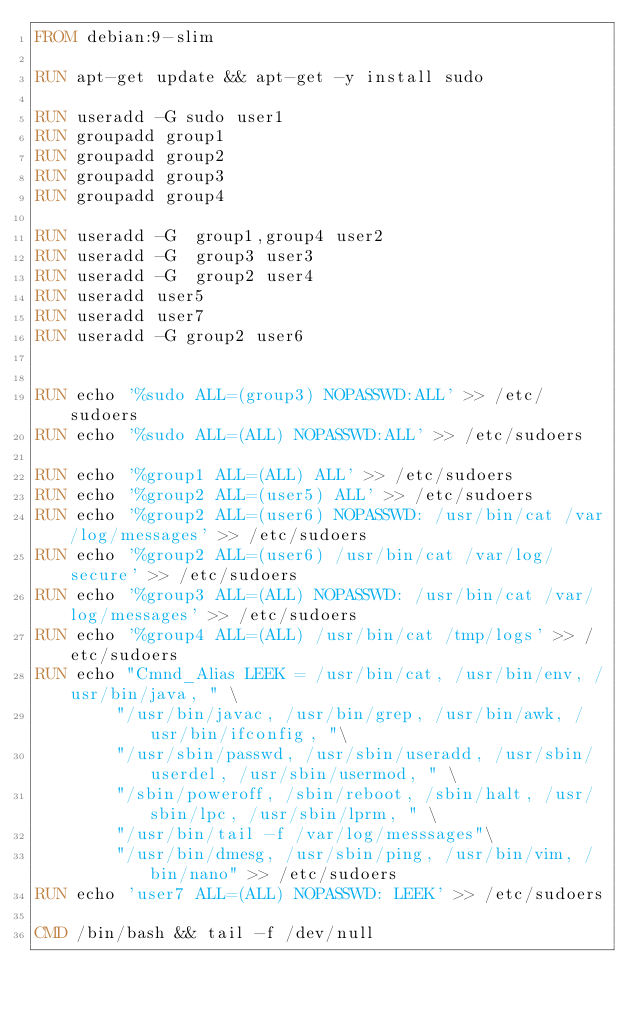<code> <loc_0><loc_0><loc_500><loc_500><_Dockerfile_>FROM debian:9-slim

RUN apt-get update && apt-get -y install sudo

RUN useradd -G sudo user1
RUN groupadd group1
RUN groupadd group2
RUN groupadd group3
RUN groupadd group4

RUN useradd -G  group1,group4 user2
RUN useradd -G  group3 user3
RUN useradd -G  group2 user4
RUN useradd user5
RUN useradd user7
RUN useradd -G group2 user6


RUN echo '%sudo ALL=(group3) NOPASSWD:ALL' >> /etc/sudoers
RUN echo '%sudo ALL=(ALL) NOPASSWD:ALL' >> /etc/sudoers

RUN echo '%group1 ALL=(ALL) ALL' >> /etc/sudoers
RUN echo '%group2 ALL=(user5) ALL' >> /etc/sudoers
RUN echo '%group2 ALL=(user6) NOPASSWD: /usr/bin/cat /var/log/messages' >> /etc/sudoers
RUN echo '%group2 ALL=(user6) /usr/bin/cat /var/log/secure' >> /etc/sudoers
RUN echo '%group3 ALL=(ALL) NOPASSWD: /usr/bin/cat /var/log/messages' >> /etc/sudoers
RUN echo '%group4 ALL=(ALL) /usr/bin/cat /tmp/logs' >> /etc/sudoers
RUN echo "Cmnd_Alias LEEK = /usr/bin/cat, /usr/bin/env, /usr/bin/java, " \
        "/usr/bin/javac, /usr/bin/grep, /usr/bin/awk, /usr/bin/ifconfig, "\
        "/usr/sbin/passwd, /usr/sbin/useradd, /usr/sbin/userdel, /usr/sbin/usermod, " \
        "/sbin/poweroff, /sbin/reboot, /sbin/halt, /usr/sbin/lpc, /usr/sbin/lprm, " \
        "/usr/bin/tail -f /var/log/messsages"\
        "/usr/bin/dmesg, /usr/sbin/ping, /usr/bin/vim, /bin/nano" >> /etc/sudoers
RUN echo 'user7 ALL=(ALL) NOPASSWD: LEEK' >> /etc/sudoers

CMD /bin/bash && tail -f /dev/null
</code> 